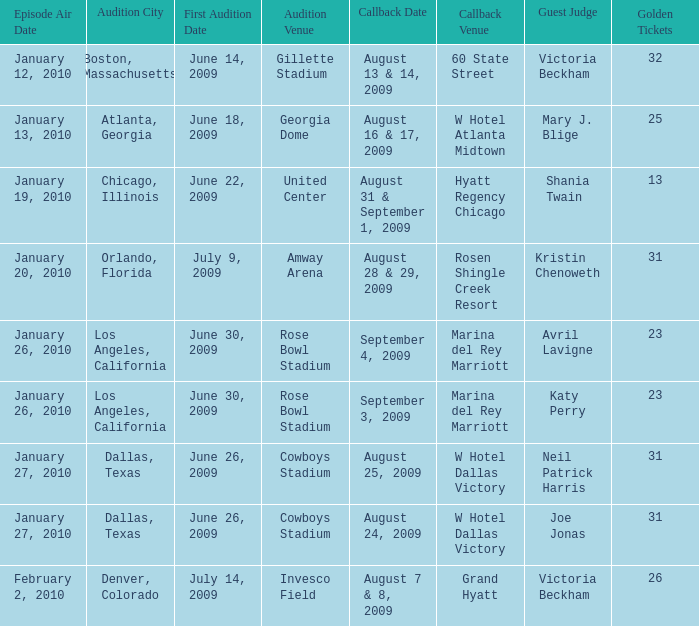How many golden tickets are there in total at rosen shingle creek resort? 1.0. 